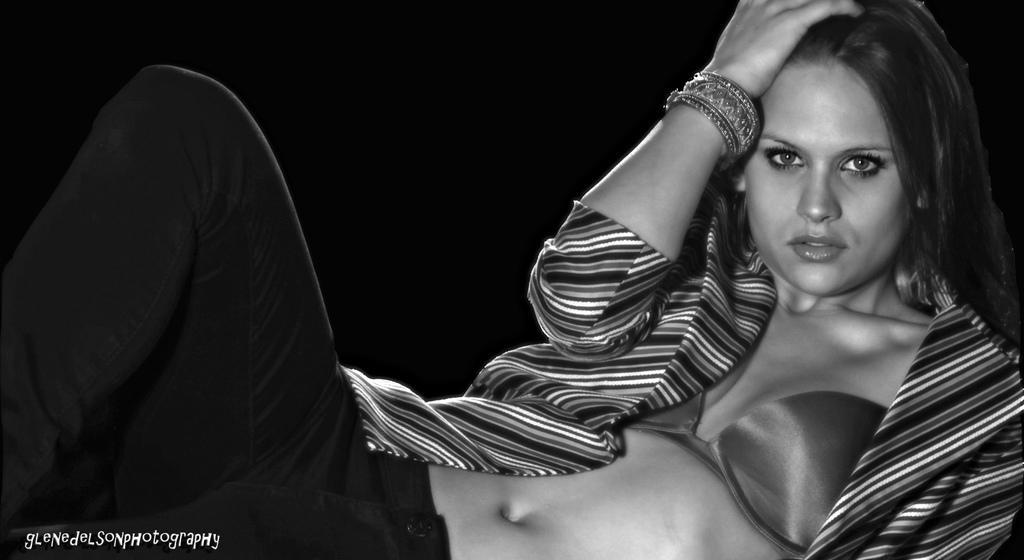Please provide a concise description of this image. In this picture we can observe a woman. She is wearing a coat. The background is completely dark. This is a black and white image. We can observe a watermark on the left side. 